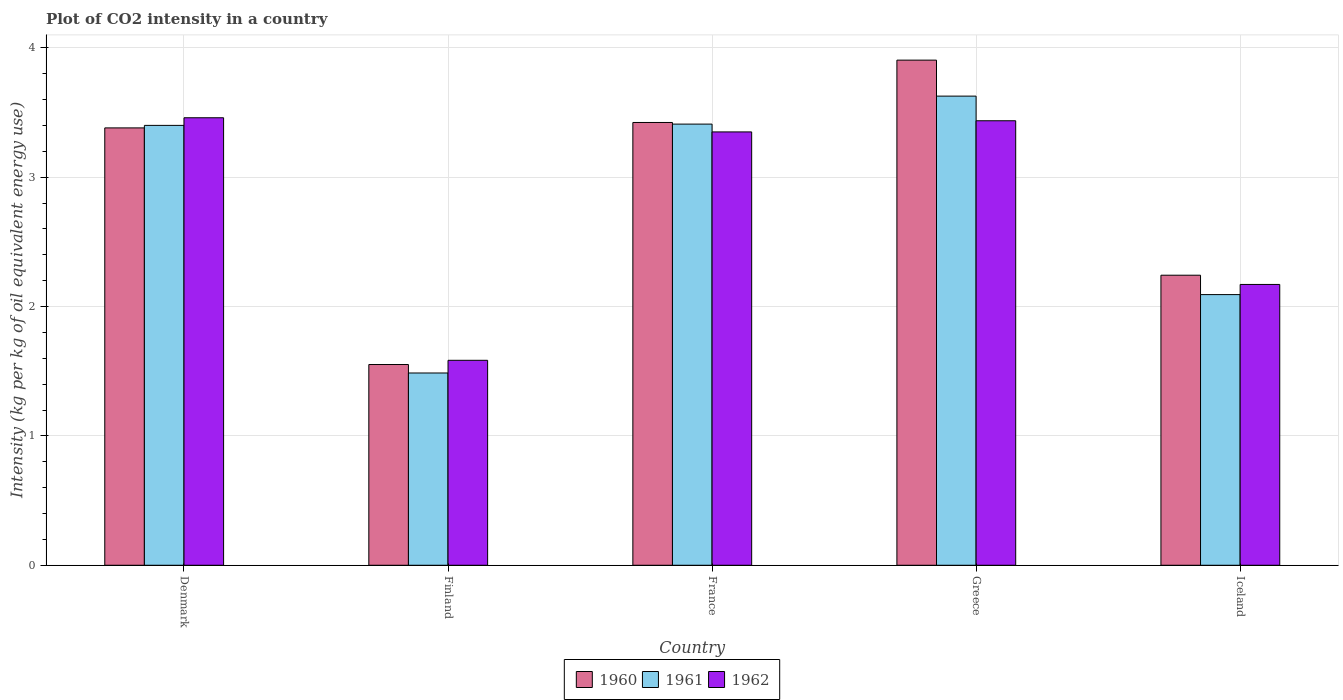Are the number of bars per tick equal to the number of legend labels?
Offer a very short reply. Yes. How many bars are there on the 5th tick from the left?
Give a very brief answer. 3. What is the label of the 2nd group of bars from the left?
Your response must be concise. Finland. In how many cases, is the number of bars for a given country not equal to the number of legend labels?
Your answer should be very brief. 0. What is the CO2 intensity in in 1960 in Iceland?
Your response must be concise. 2.24. Across all countries, what is the maximum CO2 intensity in in 1962?
Provide a succinct answer. 3.46. Across all countries, what is the minimum CO2 intensity in in 1961?
Make the answer very short. 1.49. What is the total CO2 intensity in in 1961 in the graph?
Give a very brief answer. 14.02. What is the difference between the CO2 intensity in in 1961 in France and that in Iceland?
Offer a very short reply. 1.32. What is the difference between the CO2 intensity in in 1961 in France and the CO2 intensity in in 1962 in Iceland?
Offer a terse response. 1.24. What is the average CO2 intensity in in 1961 per country?
Ensure brevity in your answer.  2.8. What is the difference between the CO2 intensity in of/in 1960 and CO2 intensity in of/in 1962 in Finland?
Your answer should be very brief. -0.03. What is the ratio of the CO2 intensity in in 1960 in France to that in Iceland?
Your response must be concise. 1.53. Is the CO2 intensity in in 1962 in Finland less than that in Greece?
Make the answer very short. Yes. Is the difference between the CO2 intensity in in 1960 in Finland and Greece greater than the difference between the CO2 intensity in in 1962 in Finland and Greece?
Give a very brief answer. No. What is the difference between the highest and the second highest CO2 intensity in in 1960?
Make the answer very short. -0.48. What is the difference between the highest and the lowest CO2 intensity in in 1961?
Your answer should be very brief. 2.14. What does the 1st bar from the left in Greece represents?
Keep it short and to the point. 1960. Are all the bars in the graph horizontal?
Offer a terse response. No. How many countries are there in the graph?
Your answer should be compact. 5. Are the values on the major ticks of Y-axis written in scientific E-notation?
Ensure brevity in your answer.  No. Does the graph contain grids?
Keep it short and to the point. Yes. Where does the legend appear in the graph?
Make the answer very short. Bottom center. How many legend labels are there?
Ensure brevity in your answer.  3. How are the legend labels stacked?
Your answer should be compact. Horizontal. What is the title of the graph?
Keep it short and to the point. Plot of CO2 intensity in a country. What is the label or title of the X-axis?
Give a very brief answer. Country. What is the label or title of the Y-axis?
Offer a terse response. Intensity (kg per kg of oil equivalent energy use). What is the Intensity (kg per kg of oil equivalent energy use) of 1960 in Denmark?
Your answer should be very brief. 3.38. What is the Intensity (kg per kg of oil equivalent energy use) of 1961 in Denmark?
Your answer should be compact. 3.4. What is the Intensity (kg per kg of oil equivalent energy use) in 1962 in Denmark?
Make the answer very short. 3.46. What is the Intensity (kg per kg of oil equivalent energy use) of 1960 in Finland?
Offer a very short reply. 1.55. What is the Intensity (kg per kg of oil equivalent energy use) of 1961 in Finland?
Your response must be concise. 1.49. What is the Intensity (kg per kg of oil equivalent energy use) in 1962 in Finland?
Your answer should be very brief. 1.58. What is the Intensity (kg per kg of oil equivalent energy use) of 1960 in France?
Ensure brevity in your answer.  3.42. What is the Intensity (kg per kg of oil equivalent energy use) of 1961 in France?
Your answer should be very brief. 3.41. What is the Intensity (kg per kg of oil equivalent energy use) in 1962 in France?
Your answer should be very brief. 3.35. What is the Intensity (kg per kg of oil equivalent energy use) of 1960 in Greece?
Keep it short and to the point. 3.91. What is the Intensity (kg per kg of oil equivalent energy use) in 1961 in Greece?
Offer a very short reply. 3.63. What is the Intensity (kg per kg of oil equivalent energy use) of 1962 in Greece?
Give a very brief answer. 3.44. What is the Intensity (kg per kg of oil equivalent energy use) in 1960 in Iceland?
Give a very brief answer. 2.24. What is the Intensity (kg per kg of oil equivalent energy use) of 1961 in Iceland?
Provide a short and direct response. 2.09. What is the Intensity (kg per kg of oil equivalent energy use) of 1962 in Iceland?
Offer a very short reply. 2.17. Across all countries, what is the maximum Intensity (kg per kg of oil equivalent energy use) of 1960?
Your answer should be very brief. 3.91. Across all countries, what is the maximum Intensity (kg per kg of oil equivalent energy use) of 1961?
Ensure brevity in your answer.  3.63. Across all countries, what is the maximum Intensity (kg per kg of oil equivalent energy use) of 1962?
Offer a very short reply. 3.46. Across all countries, what is the minimum Intensity (kg per kg of oil equivalent energy use) of 1960?
Provide a succinct answer. 1.55. Across all countries, what is the minimum Intensity (kg per kg of oil equivalent energy use) of 1961?
Ensure brevity in your answer.  1.49. Across all countries, what is the minimum Intensity (kg per kg of oil equivalent energy use) in 1962?
Your response must be concise. 1.58. What is the total Intensity (kg per kg of oil equivalent energy use) in 1960 in the graph?
Your answer should be compact. 14.51. What is the total Intensity (kg per kg of oil equivalent energy use) of 1961 in the graph?
Your answer should be compact. 14.02. What is the total Intensity (kg per kg of oil equivalent energy use) in 1962 in the graph?
Make the answer very short. 14. What is the difference between the Intensity (kg per kg of oil equivalent energy use) of 1960 in Denmark and that in Finland?
Your answer should be very brief. 1.83. What is the difference between the Intensity (kg per kg of oil equivalent energy use) in 1961 in Denmark and that in Finland?
Ensure brevity in your answer.  1.91. What is the difference between the Intensity (kg per kg of oil equivalent energy use) of 1962 in Denmark and that in Finland?
Your answer should be very brief. 1.88. What is the difference between the Intensity (kg per kg of oil equivalent energy use) of 1960 in Denmark and that in France?
Offer a very short reply. -0.04. What is the difference between the Intensity (kg per kg of oil equivalent energy use) of 1961 in Denmark and that in France?
Ensure brevity in your answer.  -0.01. What is the difference between the Intensity (kg per kg of oil equivalent energy use) in 1962 in Denmark and that in France?
Give a very brief answer. 0.11. What is the difference between the Intensity (kg per kg of oil equivalent energy use) in 1960 in Denmark and that in Greece?
Your answer should be very brief. -0.52. What is the difference between the Intensity (kg per kg of oil equivalent energy use) of 1961 in Denmark and that in Greece?
Provide a succinct answer. -0.23. What is the difference between the Intensity (kg per kg of oil equivalent energy use) in 1962 in Denmark and that in Greece?
Ensure brevity in your answer.  0.02. What is the difference between the Intensity (kg per kg of oil equivalent energy use) in 1960 in Denmark and that in Iceland?
Offer a very short reply. 1.14. What is the difference between the Intensity (kg per kg of oil equivalent energy use) in 1961 in Denmark and that in Iceland?
Provide a succinct answer. 1.31. What is the difference between the Intensity (kg per kg of oil equivalent energy use) of 1962 in Denmark and that in Iceland?
Ensure brevity in your answer.  1.29. What is the difference between the Intensity (kg per kg of oil equivalent energy use) in 1960 in Finland and that in France?
Your answer should be very brief. -1.87. What is the difference between the Intensity (kg per kg of oil equivalent energy use) in 1961 in Finland and that in France?
Your answer should be very brief. -1.92. What is the difference between the Intensity (kg per kg of oil equivalent energy use) in 1962 in Finland and that in France?
Give a very brief answer. -1.77. What is the difference between the Intensity (kg per kg of oil equivalent energy use) in 1960 in Finland and that in Greece?
Ensure brevity in your answer.  -2.35. What is the difference between the Intensity (kg per kg of oil equivalent energy use) in 1961 in Finland and that in Greece?
Your answer should be very brief. -2.14. What is the difference between the Intensity (kg per kg of oil equivalent energy use) in 1962 in Finland and that in Greece?
Your answer should be compact. -1.85. What is the difference between the Intensity (kg per kg of oil equivalent energy use) of 1960 in Finland and that in Iceland?
Keep it short and to the point. -0.69. What is the difference between the Intensity (kg per kg of oil equivalent energy use) in 1961 in Finland and that in Iceland?
Offer a terse response. -0.61. What is the difference between the Intensity (kg per kg of oil equivalent energy use) in 1962 in Finland and that in Iceland?
Provide a short and direct response. -0.59. What is the difference between the Intensity (kg per kg of oil equivalent energy use) in 1960 in France and that in Greece?
Ensure brevity in your answer.  -0.48. What is the difference between the Intensity (kg per kg of oil equivalent energy use) of 1961 in France and that in Greece?
Provide a succinct answer. -0.22. What is the difference between the Intensity (kg per kg of oil equivalent energy use) of 1962 in France and that in Greece?
Make the answer very short. -0.09. What is the difference between the Intensity (kg per kg of oil equivalent energy use) of 1960 in France and that in Iceland?
Your answer should be compact. 1.18. What is the difference between the Intensity (kg per kg of oil equivalent energy use) in 1961 in France and that in Iceland?
Offer a terse response. 1.32. What is the difference between the Intensity (kg per kg of oil equivalent energy use) of 1962 in France and that in Iceland?
Your answer should be very brief. 1.18. What is the difference between the Intensity (kg per kg of oil equivalent energy use) of 1960 in Greece and that in Iceland?
Your response must be concise. 1.66. What is the difference between the Intensity (kg per kg of oil equivalent energy use) in 1961 in Greece and that in Iceland?
Keep it short and to the point. 1.53. What is the difference between the Intensity (kg per kg of oil equivalent energy use) of 1962 in Greece and that in Iceland?
Provide a short and direct response. 1.27. What is the difference between the Intensity (kg per kg of oil equivalent energy use) of 1960 in Denmark and the Intensity (kg per kg of oil equivalent energy use) of 1961 in Finland?
Keep it short and to the point. 1.9. What is the difference between the Intensity (kg per kg of oil equivalent energy use) in 1960 in Denmark and the Intensity (kg per kg of oil equivalent energy use) in 1962 in Finland?
Give a very brief answer. 1.8. What is the difference between the Intensity (kg per kg of oil equivalent energy use) of 1961 in Denmark and the Intensity (kg per kg of oil equivalent energy use) of 1962 in Finland?
Make the answer very short. 1.82. What is the difference between the Intensity (kg per kg of oil equivalent energy use) of 1960 in Denmark and the Intensity (kg per kg of oil equivalent energy use) of 1961 in France?
Your answer should be compact. -0.03. What is the difference between the Intensity (kg per kg of oil equivalent energy use) in 1960 in Denmark and the Intensity (kg per kg of oil equivalent energy use) in 1962 in France?
Provide a succinct answer. 0.03. What is the difference between the Intensity (kg per kg of oil equivalent energy use) in 1961 in Denmark and the Intensity (kg per kg of oil equivalent energy use) in 1962 in France?
Your answer should be compact. 0.05. What is the difference between the Intensity (kg per kg of oil equivalent energy use) of 1960 in Denmark and the Intensity (kg per kg of oil equivalent energy use) of 1961 in Greece?
Make the answer very short. -0.25. What is the difference between the Intensity (kg per kg of oil equivalent energy use) of 1960 in Denmark and the Intensity (kg per kg of oil equivalent energy use) of 1962 in Greece?
Give a very brief answer. -0.06. What is the difference between the Intensity (kg per kg of oil equivalent energy use) of 1961 in Denmark and the Intensity (kg per kg of oil equivalent energy use) of 1962 in Greece?
Offer a very short reply. -0.04. What is the difference between the Intensity (kg per kg of oil equivalent energy use) of 1960 in Denmark and the Intensity (kg per kg of oil equivalent energy use) of 1961 in Iceland?
Your answer should be very brief. 1.29. What is the difference between the Intensity (kg per kg of oil equivalent energy use) of 1960 in Denmark and the Intensity (kg per kg of oil equivalent energy use) of 1962 in Iceland?
Offer a terse response. 1.21. What is the difference between the Intensity (kg per kg of oil equivalent energy use) in 1961 in Denmark and the Intensity (kg per kg of oil equivalent energy use) in 1962 in Iceland?
Offer a very short reply. 1.23. What is the difference between the Intensity (kg per kg of oil equivalent energy use) in 1960 in Finland and the Intensity (kg per kg of oil equivalent energy use) in 1961 in France?
Keep it short and to the point. -1.86. What is the difference between the Intensity (kg per kg of oil equivalent energy use) of 1960 in Finland and the Intensity (kg per kg of oil equivalent energy use) of 1962 in France?
Your answer should be compact. -1.8. What is the difference between the Intensity (kg per kg of oil equivalent energy use) in 1961 in Finland and the Intensity (kg per kg of oil equivalent energy use) in 1962 in France?
Keep it short and to the point. -1.86. What is the difference between the Intensity (kg per kg of oil equivalent energy use) in 1960 in Finland and the Intensity (kg per kg of oil equivalent energy use) in 1961 in Greece?
Ensure brevity in your answer.  -2.08. What is the difference between the Intensity (kg per kg of oil equivalent energy use) in 1960 in Finland and the Intensity (kg per kg of oil equivalent energy use) in 1962 in Greece?
Your answer should be very brief. -1.88. What is the difference between the Intensity (kg per kg of oil equivalent energy use) in 1961 in Finland and the Intensity (kg per kg of oil equivalent energy use) in 1962 in Greece?
Offer a terse response. -1.95. What is the difference between the Intensity (kg per kg of oil equivalent energy use) in 1960 in Finland and the Intensity (kg per kg of oil equivalent energy use) in 1961 in Iceland?
Your answer should be compact. -0.54. What is the difference between the Intensity (kg per kg of oil equivalent energy use) in 1960 in Finland and the Intensity (kg per kg of oil equivalent energy use) in 1962 in Iceland?
Offer a terse response. -0.62. What is the difference between the Intensity (kg per kg of oil equivalent energy use) of 1961 in Finland and the Intensity (kg per kg of oil equivalent energy use) of 1962 in Iceland?
Make the answer very short. -0.68. What is the difference between the Intensity (kg per kg of oil equivalent energy use) in 1960 in France and the Intensity (kg per kg of oil equivalent energy use) in 1961 in Greece?
Your answer should be compact. -0.2. What is the difference between the Intensity (kg per kg of oil equivalent energy use) in 1960 in France and the Intensity (kg per kg of oil equivalent energy use) in 1962 in Greece?
Your response must be concise. -0.01. What is the difference between the Intensity (kg per kg of oil equivalent energy use) of 1961 in France and the Intensity (kg per kg of oil equivalent energy use) of 1962 in Greece?
Give a very brief answer. -0.03. What is the difference between the Intensity (kg per kg of oil equivalent energy use) of 1960 in France and the Intensity (kg per kg of oil equivalent energy use) of 1961 in Iceland?
Your answer should be very brief. 1.33. What is the difference between the Intensity (kg per kg of oil equivalent energy use) of 1960 in France and the Intensity (kg per kg of oil equivalent energy use) of 1962 in Iceland?
Keep it short and to the point. 1.25. What is the difference between the Intensity (kg per kg of oil equivalent energy use) in 1961 in France and the Intensity (kg per kg of oil equivalent energy use) in 1962 in Iceland?
Offer a terse response. 1.24. What is the difference between the Intensity (kg per kg of oil equivalent energy use) of 1960 in Greece and the Intensity (kg per kg of oil equivalent energy use) of 1961 in Iceland?
Offer a terse response. 1.81. What is the difference between the Intensity (kg per kg of oil equivalent energy use) of 1960 in Greece and the Intensity (kg per kg of oil equivalent energy use) of 1962 in Iceland?
Your response must be concise. 1.73. What is the difference between the Intensity (kg per kg of oil equivalent energy use) in 1961 in Greece and the Intensity (kg per kg of oil equivalent energy use) in 1962 in Iceland?
Your response must be concise. 1.46. What is the average Intensity (kg per kg of oil equivalent energy use) of 1960 per country?
Your answer should be very brief. 2.9. What is the average Intensity (kg per kg of oil equivalent energy use) in 1961 per country?
Offer a very short reply. 2.8. What is the average Intensity (kg per kg of oil equivalent energy use) of 1962 per country?
Provide a short and direct response. 2.8. What is the difference between the Intensity (kg per kg of oil equivalent energy use) in 1960 and Intensity (kg per kg of oil equivalent energy use) in 1961 in Denmark?
Your answer should be compact. -0.02. What is the difference between the Intensity (kg per kg of oil equivalent energy use) of 1960 and Intensity (kg per kg of oil equivalent energy use) of 1962 in Denmark?
Ensure brevity in your answer.  -0.08. What is the difference between the Intensity (kg per kg of oil equivalent energy use) in 1961 and Intensity (kg per kg of oil equivalent energy use) in 1962 in Denmark?
Your answer should be very brief. -0.06. What is the difference between the Intensity (kg per kg of oil equivalent energy use) in 1960 and Intensity (kg per kg of oil equivalent energy use) in 1961 in Finland?
Keep it short and to the point. 0.07. What is the difference between the Intensity (kg per kg of oil equivalent energy use) in 1960 and Intensity (kg per kg of oil equivalent energy use) in 1962 in Finland?
Offer a terse response. -0.03. What is the difference between the Intensity (kg per kg of oil equivalent energy use) of 1961 and Intensity (kg per kg of oil equivalent energy use) of 1962 in Finland?
Offer a terse response. -0.1. What is the difference between the Intensity (kg per kg of oil equivalent energy use) of 1960 and Intensity (kg per kg of oil equivalent energy use) of 1961 in France?
Provide a short and direct response. 0.01. What is the difference between the Intensity (kg per kg of oil equivalent energy use) of 1960 and Intensity (kg per kg of oil equivalent energy use) of 1962 in France?
Your response must be concise. 0.07. What is the difference between the Intensity (kg per kg of oil equivalent energy use) in 1961 and Intensity (kg per kg of oil equivalent energy use) in 1962 in France?
Give a very brief answer. 0.06. What is the difference between the Intensity (kg per kg of oil equivalent energy use) in 1960 and Intensity (kg per kg of oil equivalent energy use) in 1961 in Greece?
Make the answer very short. 0.28. What is the difference between the Intensity (kg per kg of oil equivalent energy use) of 1960 and Intensity (kg per kg of oil equivalent energy use) of 1962 in Greece?
Offer a terse response. 0.47. What is the difference between the Intensity (kg per kg of oil equivalent energy use) in 1961 and Intensity (kg per kg of oil equivalent energy use) in 1962 in Greece?
Your answer should be very brief. 0.19. What is the difference between the Intensity (kg per kg of oil equivalent energy use) of 1960 and Intensity (kg per kg of oil equivalent energy use) of 1961 in Iceland?
Offer a very short reply. 0.15. What is the difference between the Intensity (kg per kg of oil equivalent energy use) in 1960 and Intensity (kg per kg of oil equivalent energy use) in 1962 in Iceland?
Your answer should be very brief. 0.07. What is the difference between the Intensity (kg per kg of oil equivalent energy use) in 1961 and Intensity (kg per kg of oil equivalent energy use) in 1962 in Iceland?
Provide a short and direct response. -0.08. What is the ratio of the Intensity (kg per kg of oil equivalent energy use) in 1960 in Denmark to that in Finland?
Offer a very short reply. 2.18. What is the ratio of the Intensity (kg per kg of oil equivalent energy use) in 1961 in Denmark to that in Finland?
Provide a succinct answer. 2.29. What is the ratio of the Intensity (kg per kg of oil equivalent energy use) in 1962 in Denmark to that in Finland?
Provide a succinct answer. 2.18. What is the ratio of the Intensity (kg per kg of oil equivalent energy use) of 1960 in Denmark to that in France?
Your answer should be compact. 0.99. What is the ratio of the Intensity (kg per kg of oil equivalent energy use) in 1961 in Denmark to that in France?
Provide a short and direct response. 1. What is the ratio of the Intensity (kg per kg of oil equivalent energy use) of 1962 in Denmark to that in France?
Offer a very short reply. 1.03. What is the ratio of the Intensity (kg per kg of oil equivalent energy use) in 1960 in Denmark to that in Greece?
Ensure brevity in your answer.  0.87. What is the ratio of the Intensity (kg per kg of oil equivalent energy use) of 1961 in Denmark to that in Greece?
Ensure brevity in your answer.  0.94. What is the ratio of the Intensity (kg per kg of oil equivalent energy use) in 1962 in Denmark to that in Greece?
Give a very brief answer. 1.01. What is the ratio of the Intensity (kg per kg of oil equivalent energy use) of 1960 in Denmark to that in Iceland?
Ensure brevity in your answer.  1.51. What is the ratio of the Intensity (kg per kg of oil equivalent energy use) in 1961 in Denmark to that in Iceland?
Keep it short and to the point. 1.63. What is the ratio of the Intensity (kg per kg of oil equivalent energy use) in 1962 in Denmark to that in Iceland?
Keep it short and to the point. 1.59. What is the ratio of the Intensity (kg per kg of oil equivalent energy use) in 1960 in Finland to that in France?
Ensure brevity in your answer.  0.45. What is the ratio of the Intensity (kg per kg of oil equivalent energy use) in 1961 in Finland to that in France?
Offer a terse response. 0.44. What is the ratio of the Intensity (kg per kg of oil equivalent energy use) of 1962 in Finland to that in France?
Your response must be concise. 0.47. What is the ratio of the Intensity (kg per kg of oil equivalent energy use) in 1960 in Finland to that in Greece?
Keep it short and to the point. 0.4. What is the ratio of the Intensity (kg per kg of oil equivalent energy use) in 1961 in Finland to that in Greece?
Make the answer very short. 0.41. What is the ratio of the Intensity (kg per kg of oil equivalent energy use) of 1962 in Finland to that in Greece?
Provide a short and direct response. 0.46. What is the ratio of the Intensity (kg per kg of oil equivalent energy use) in 1960 in Finland to that in Iceland?
Provide a short and direct response. 0.69. What is the ratio of the Intensity (kg per kg of oil equivalent energy use) in 1961 in Finland to that in Iceland?
Your answer should be compact. 0.71. What is the ratio of the Intensity (kg per kg of oil equivalent energy use) of 1962 in Finland to that in Iceland?
Make the answer very short. 0.73. What is the ratio of the Intensity (kg per kg of oil equivalent energy use) of 1960 in France to that in Greece?
Provide a short and direct response. 0.88. What is the ratio of the Intensity (kg per kg of oil equivalent energy use) in 1961 in France to that in Greece?
Your response must be concise. 0.94. What is the ratio of the Intensity (kg per kg of oil equivalent energy use) in 1962 in France to that in Greece?
Offer a very short reply. 0.97. What is the ratio of the Intensity (kg per kg of oil equivalent energy use) of 1960 in France to that in Iceland?
Offer a very short reply. 1.53. What is the ratio of the Intensity (kg per kg of oil equivalent energy use) in 1961 in France to that in Iceland?
Your answer should be compact. 1.63. What is the ratio of the Intensity (kg per kg of oil equivalent energy use) in 1962 in France to that in Iceland?
Keep it short and to the point. 1.54. What is the ratio of the Intensity (kg per kg of oil equivalent energy use) of 1960 in Greece to that in Iceland?
Your answer should be compact. 1.74. What is the ratio of the Intensity (kg per kg of oil equivalent energy use) of 1961 in Greece to that in Iceland?
Offer a terse response. 1.73. What is the ratio of the Intensity (kg per kg of oil equivalent energy use) of 1962 in Greece to that in Iceland?
Make the answer very short. 1.58. What is the difference between the highest and the second highest Intensity (kg per kg of oil equivalent energy use) of 1960?
Give a very brief answer. 0.48. What is the difference between the highest and the second highest Intensity (kg per kg of oil equivalent energy use) in 1961?
Ensure brevity in your answer.  0.22. What is the difference between the highest and the second highest Intensity (kg per kg of oil equivalent energy use) of 1962?
Your answer should be compact. 0.02. What is the difference between the highest and the lowest Intensity (kg per kg of oil equivalent energy use) of 1960?
Make the answer very short. 2.35. What is the difference between the highest and the lowest Intensity (kg per kg of oil equivalent energy use) in 1961?
Your answer should be compact. 2.14. What is the difference between the highest and the lowest Intensity (kg per kg of oil equivalent energy use) in 1962?
Provide a succinct answer. 1.88. 